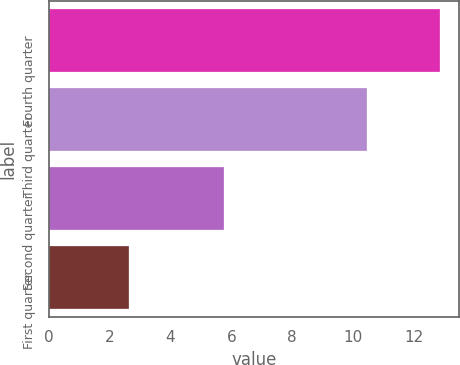<chart> <loc_0><loc_0><loc_500><loc_500><bar_chart><fcel>Fourth quarter<fcel>Third quarter<fcel>Second quarter<fcel>First quarter<nl><fcel>12.85<fcel>10.45<fcel>5.75<fcel>2.63<nl></chart> 